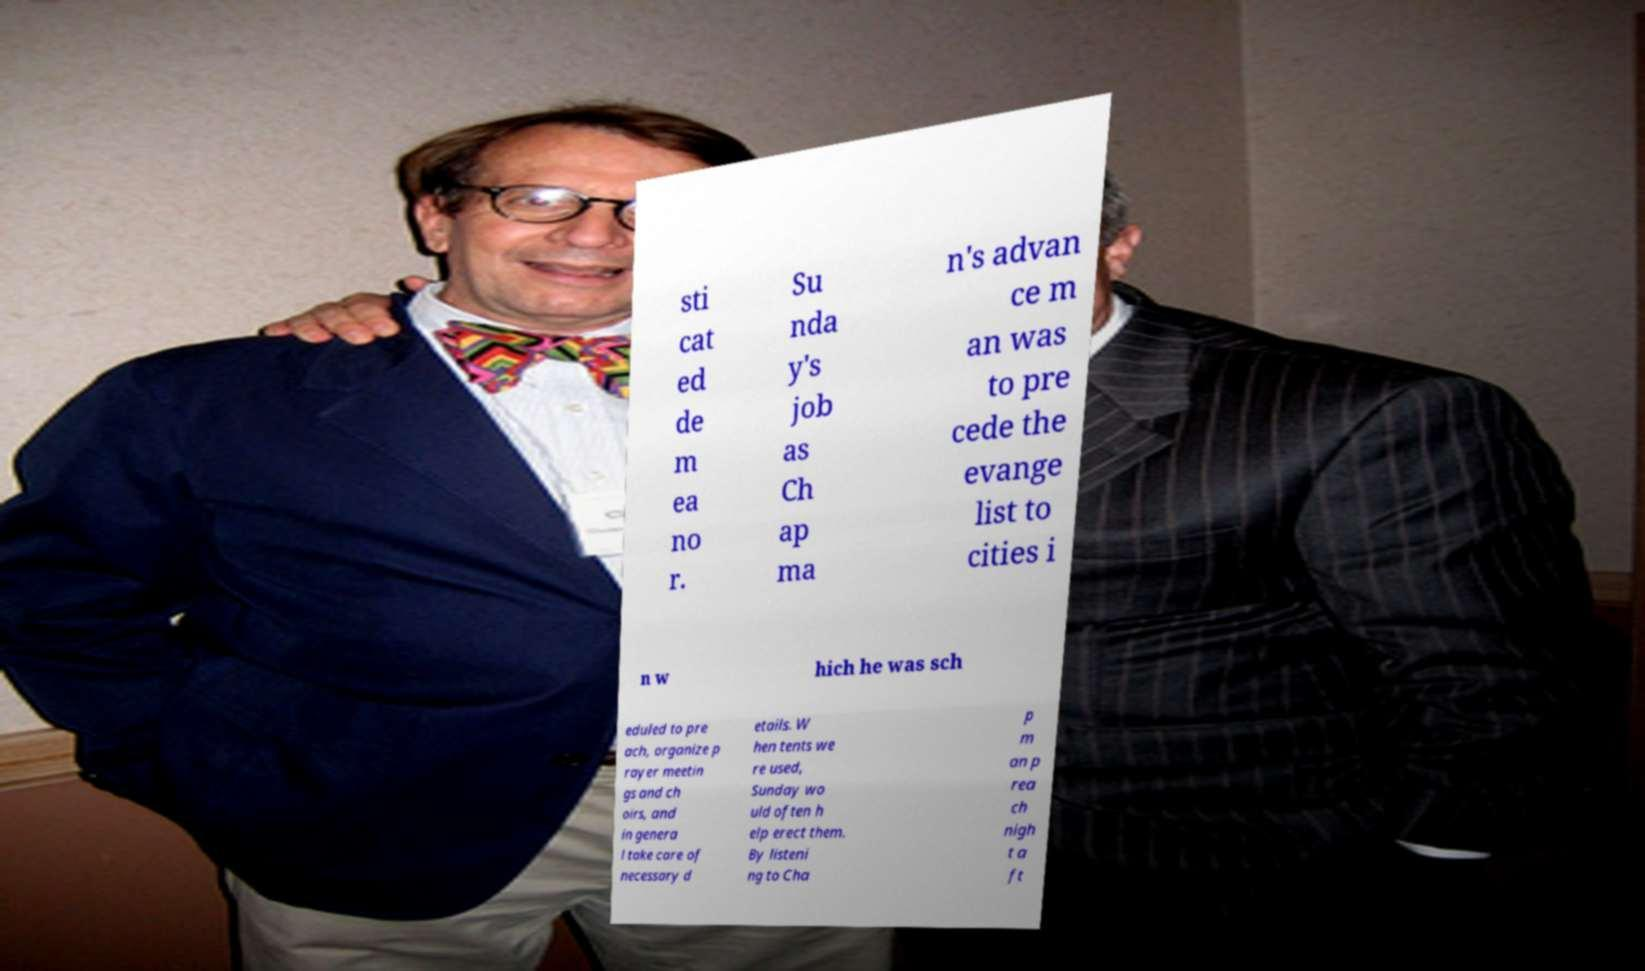Could you assist in decoding the text presented in this image and type it out clearly? sti cat ed de m ea no r. Su nda y's job as Ch ap ma n's advan ce m an was to pre cede the evange list to cities i n w hich he was sch eduled to pre ach, organize p rayer meetin gs and ch oirs, and in genera l take care of necessary d etails. W hen tents we re used, Sunday wo uld often h elp erect them. By listeni ng to Cha p m an p rea ch nigh t a ft 